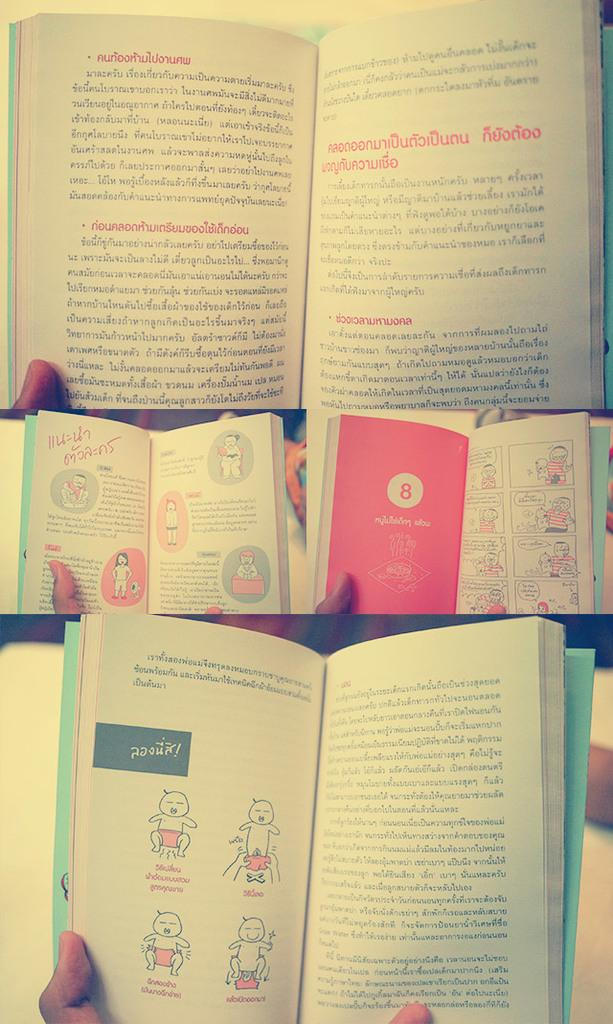<image>
Describe the image concisely. Several books open to various pages including chapter number 8. 